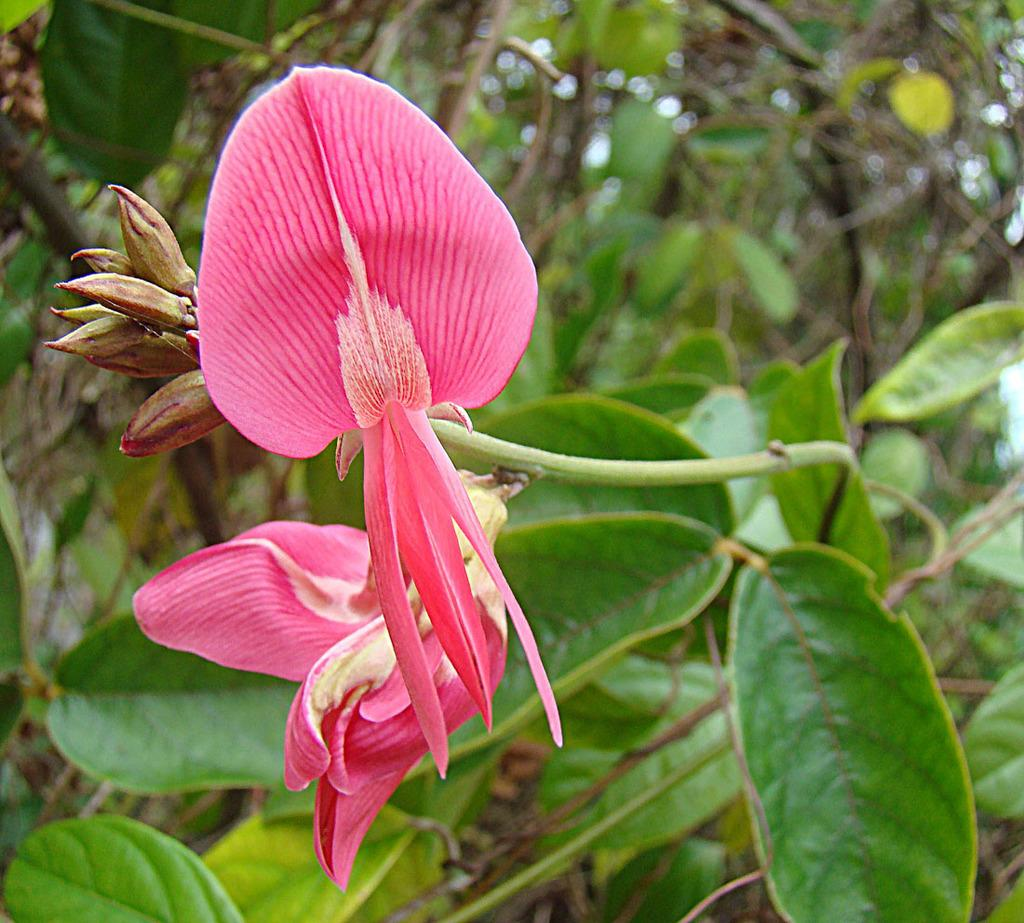What type of plant is featured in the image? There is a flower in the image. What stage of growth are the buds on the plant in the image? The buds on the plant in the image are not yet fully bloomed. What can be seen behind the flower in the image? There are other plants visible behind the flower in the image. What type of night cover is draped over the flower in the image? There is no night cover present in the image; it is a photograph of a flower during the day. 